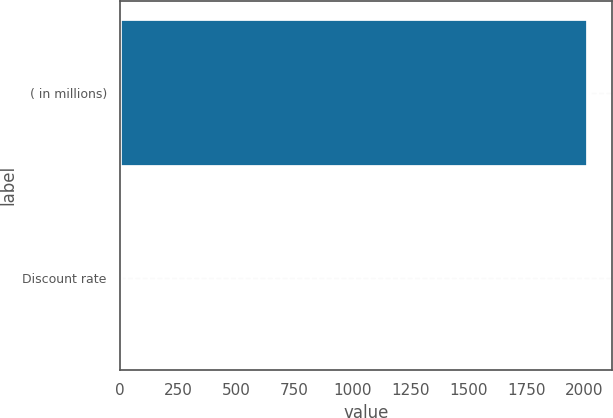Convert chart to OTSL. <chart><loc_0><loc_0><loc_500><loc_500><bar_chart><fcel>( in millions)<fcel>Discount rate<nl><fcel>2017<fcel>3.63<nl></chart> 